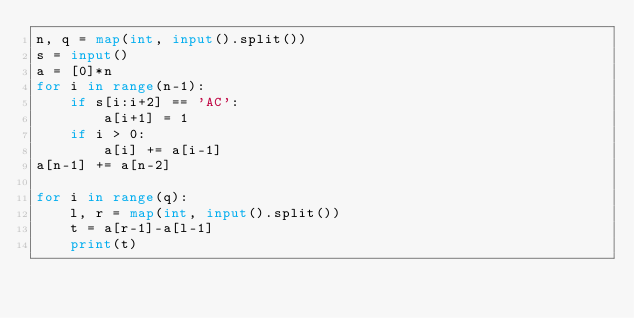<code> <loc_0><loc_0><loc_500><loc_500><_Python_>n, q = map(int, input().split())
s = input()
a = [0]*n
for i in range(n-1):
    if s[i:i+2] == 'AC':
        a[i+1] = 1
    if i > 0:
        a[i] += a[i-1]
a[n-1] += a[n-2]

for i in range(q):
    l, r = map(int, input().split())
    t = a[r-1]-a[l-1]
    print(t)
</code> 